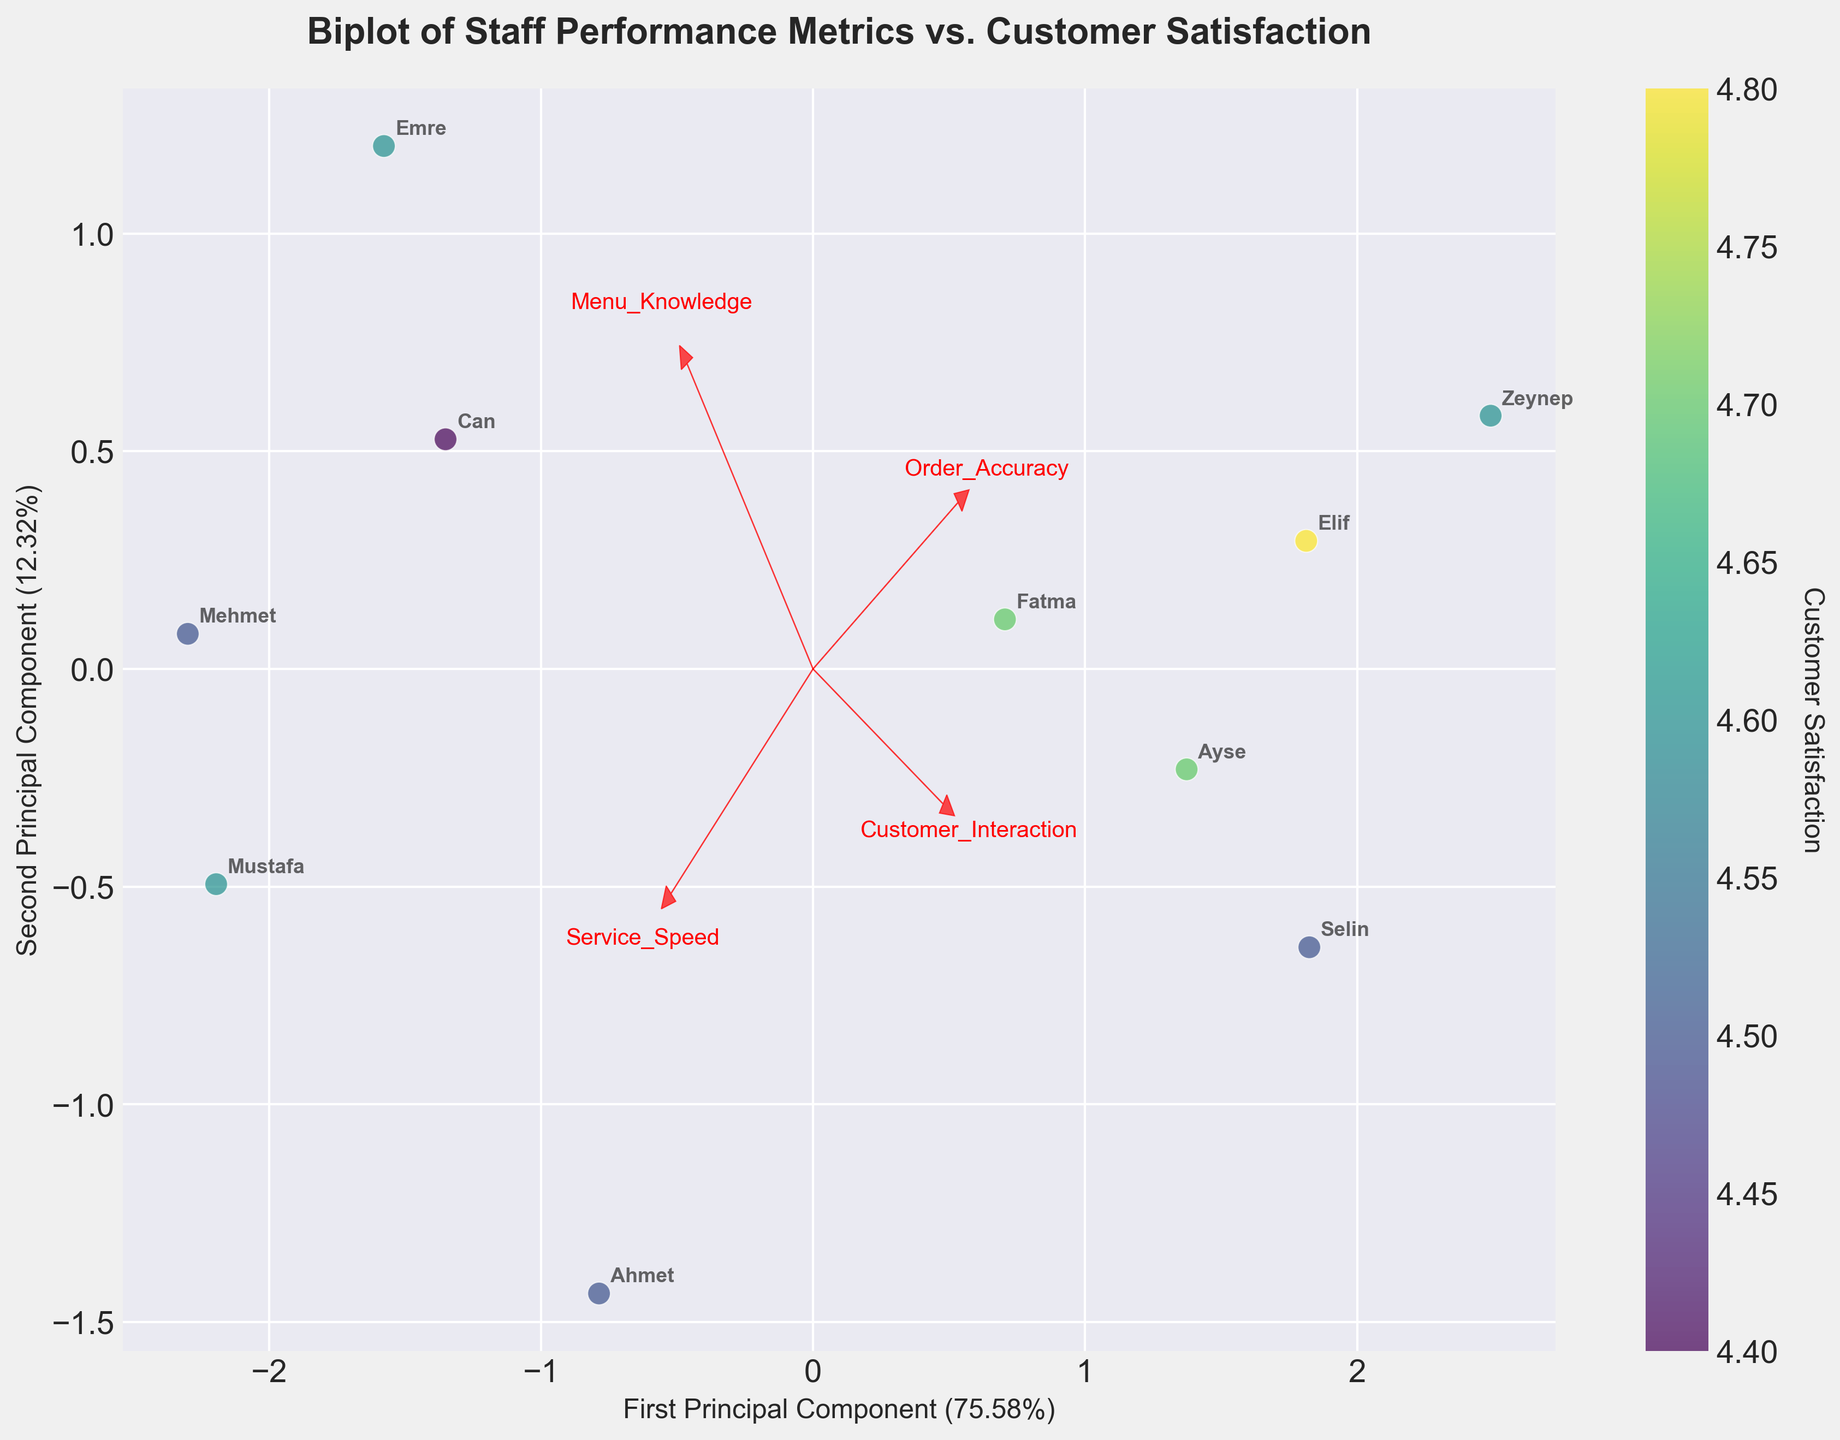What is the title of the plot? The title is at the top of the plot, it clearly states the main focus of the figure.
Answer: Biplot of Staff Performance Metrics vs. Customer Satisfaction How many staff members are represented in the plot? By counting the annotations, which are the names of the staff members scattered around the plot, we can see there are 10 names.
Answer: 10 What does the color bar represent? The color bar on the right side of the plot indicates the level of customer satisfaction, as stated by its label.
Answer: Customer Satisfaction Which staff member has the highest customer satisfaction score? By examining the color bar and matching the colors of the scatter points to the highest value on the bar, we see that Elif has the highest score.
Answer: Elif Which performance metric has the strongest influence on the first principal component? The first principal component's influence is determined by the size of the arrow pointing most closely aligned with the X-axis; Order Accuracy shows the most significant vector in this direction.
Answer: Order Accuracy Is there a staff member with a relatively low service speed but high customer satisfaction? Looking for data points where the Service Speed vector (arrow) points are lower while still having a color indicative of high satisfaction on the color bar, Ayse fits this description.
Answer: Ayse Which two performance metrics are most correlated with each other based on the biplot? Correlation in a biplot is indicated by vectors (arrows) that are closely aligned. Service Speed and Customer Interaction arrows are pointing in similar directions, suggesting they are most correlated.
Answer: Service Speed and Customer Interaction How much variance is explained by the first principal component? This information is found on the x-axis label, where the percentage is stated.
Answer: 62% Which staff member is closest to the origin of the biplot? The staff member with coordinates closest to (0, 0) on the plot is Can based on the position of his scatter point.
Answer: Can Are there any performance metrics that have a negative correlation with the second principal component? Vectors pointing in the negative direction along the Y-axis indicate negative correlation. Menu Knowledge shows the lowest directional value in regards to the second component.
Answer: Menu Knowledge 